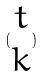Convert formula to latex. <formula><loc_0><loc_0><loc_500><loc_500>( \begin{matrix} t \\ k \end{matrix} )</formula> 